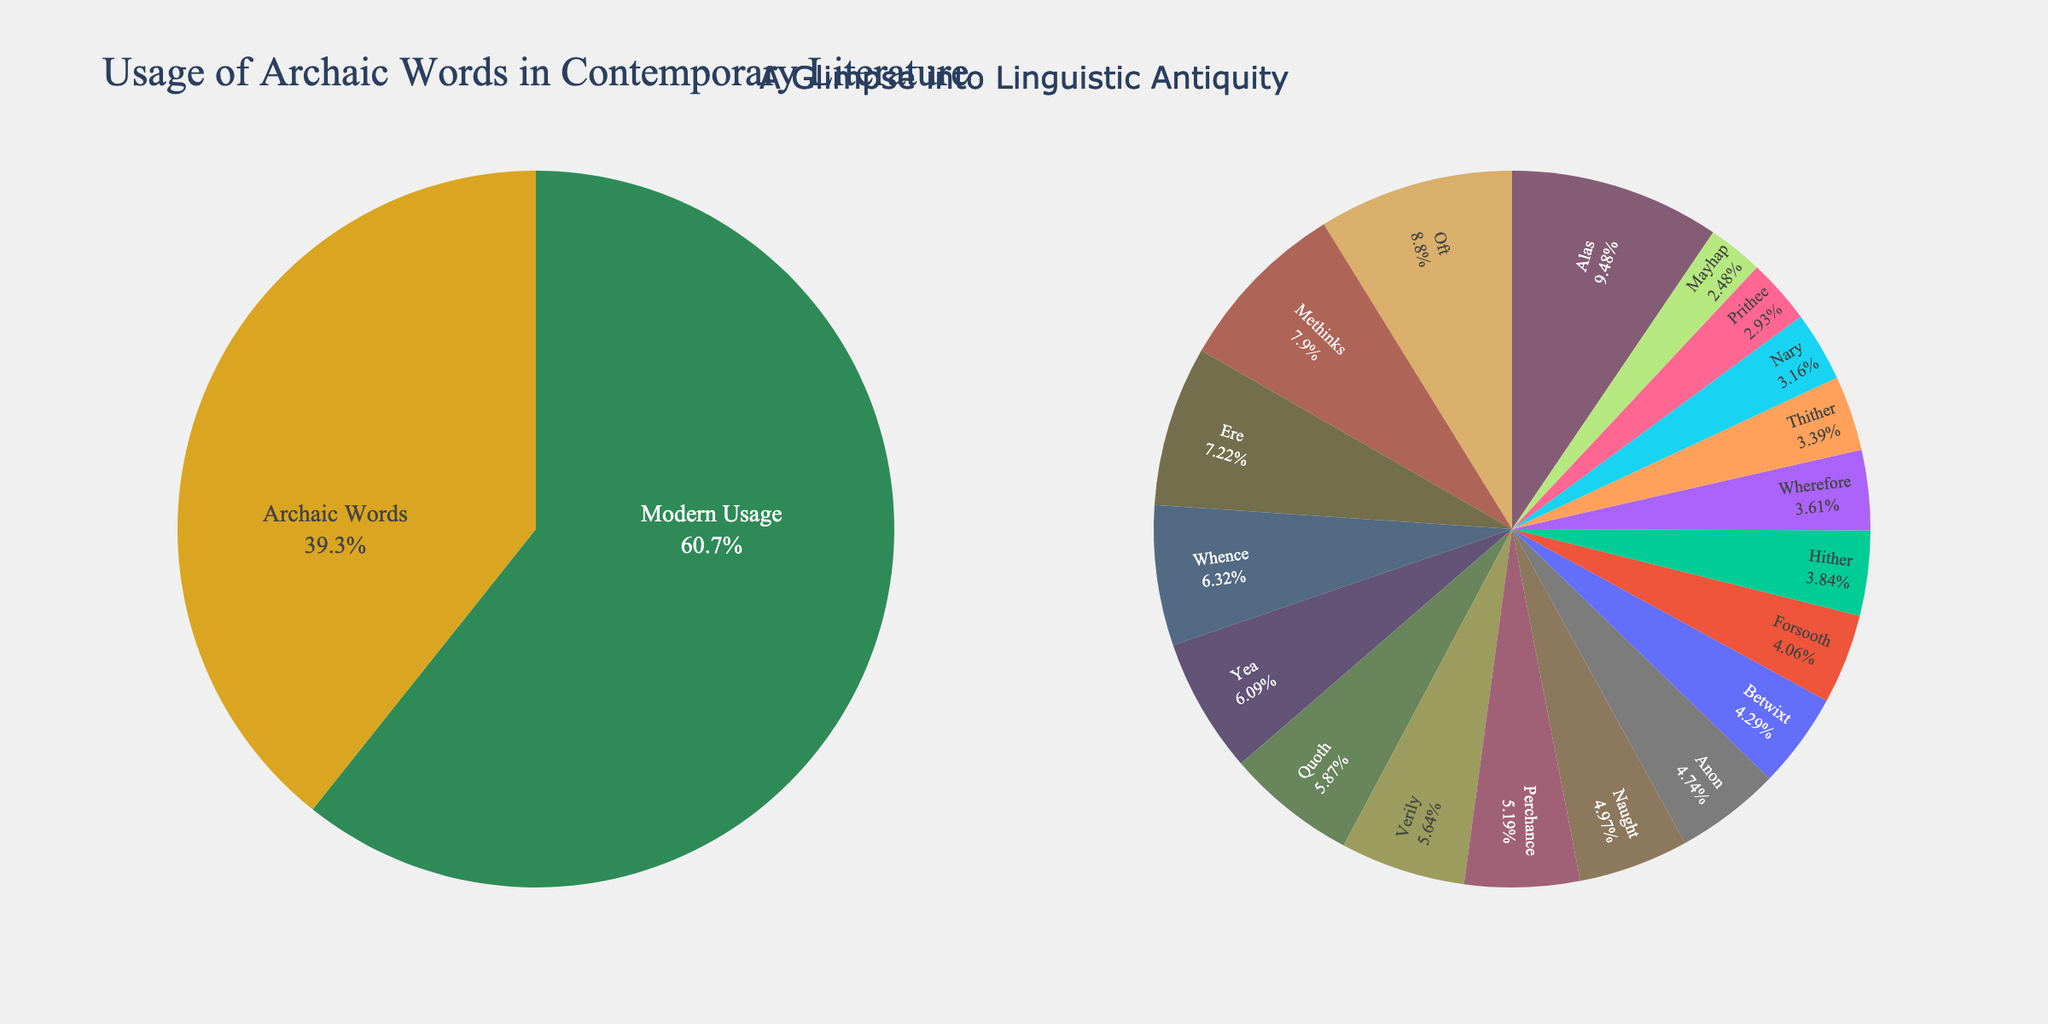What is the percentage of modern usage as compared to all archaic words? The "Overall Usage" pie chart shows the percentage of modern usage as 60.7%. The "Archaic Words Distribution" chart shows the sum of the percentages of all archaic words as 39.3%.
Answer: 60.7% Which archaic word is used the most and what is its percentage? In the "Archaic Words Distribution" pie chart, "Alas" is the slice with the highest percentage, which is 4.2%.
Answer: Alas, 4.2% Between "Oft" and "Naught," which is more frequently used in contemporary literature and by how much? The "Archaic Words Distribution" chart shows "Oft" at 3.9% and "Naught" at 2.2%. The difference is 3.9% - 2.2% = 1.7%.
Answer: Oft by 1.7% What is the sum of percentages for the least used archaic words according to the chart? The least used archaic words are "Mayhap" (1.1%), "Prithee" (1.3%), "Nary" (1.4%), "Thither" (1.5%), "Wherefore" (1.6%), and "Hither" (1.7%). Summing them up: 1.1% + 1.3% + 1.4% + 1.5% + 1.6% + 1.7% = 8.6%.
Answer: 8.6% How does the usage of "Whence" compare to that of "Verily"? In the "Archaic Words Distribution" pie chart, "Whence" is at 2.8% and "Verily" is at 2.5%. "Whence" is used 0.3% more than "Verily".
Answer: Whence by 0.3% Visualize the overall usage of arches with modern usage. Describe the color difference. In the "Overall Usage" pie chart, modern usage is marked in green and archaic words in gold.
Answer: Green for modern, Gold for archaic Which archaic words have a usage percentage higher than 3%? From the "Archaic Words Distribution" chart, the words "Alas" (4.2%), "Oft" (3.9%), "Methinks" (3.5%), "Ere" (3.2%) are all above 3%.
Answer: Alas, Oft, Methinks, Ere What is the average usage percentage for the terms "Verily," "Forsooth," and "Ere"? The percentages are: "Verily" (2.5%), "Forsooth" (1.8%), "Ere" (3.2%). The average is (2.5 + 1.8 + 3.2) / 3 = 2.5%.
Answer: 2.5% Which visual elements help identify the most used archaic word? The largest slice in the "Archaic Words Distribution" pie chart indicates the most used archaic word, additionally highlighted with a label and percentage.
Answer: Largest slice with label stapled 